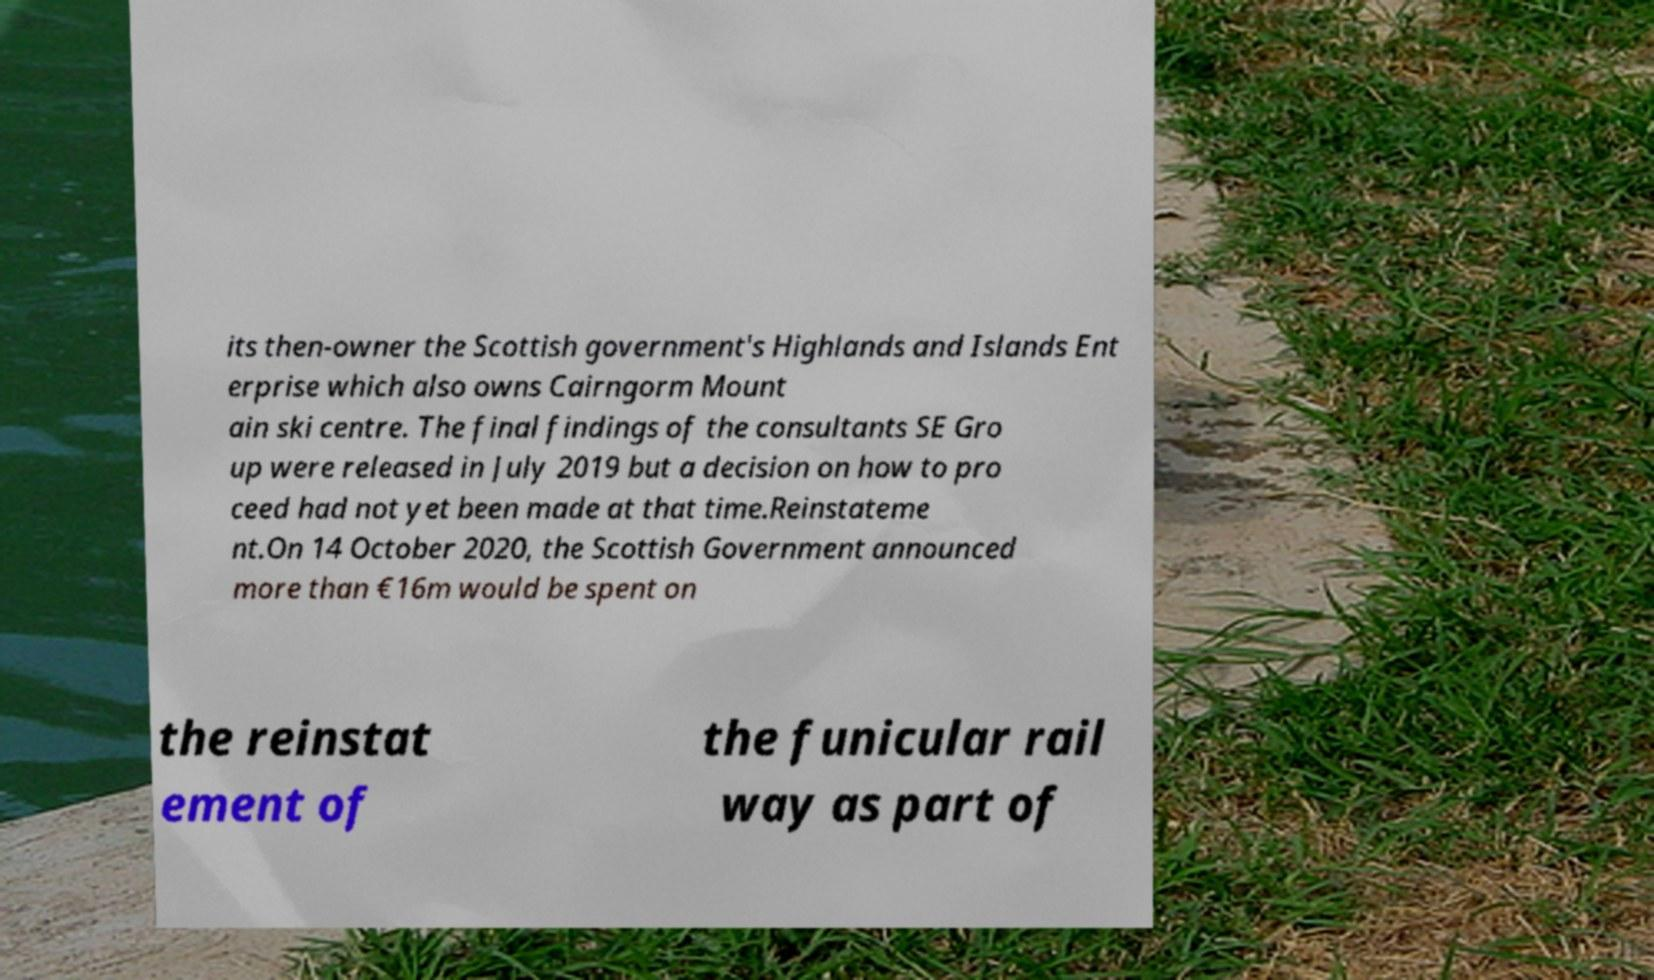What messages or text are displayed in this image? I need them in a readable, typed format. its then-owner the Scottish government's Highlands and Islands Ent erprise which also owns Cairngorm Mount ain ski centre. The final findings of the consultants SE Gro up were released in July 2019 but a decision on how to pro ceed had not yet been made at that time.Reinstateme nt.On 14 October 2020, the Scottish Government announced more than €16m would be spent on the reinstat ement of the funicular rail way as part of 